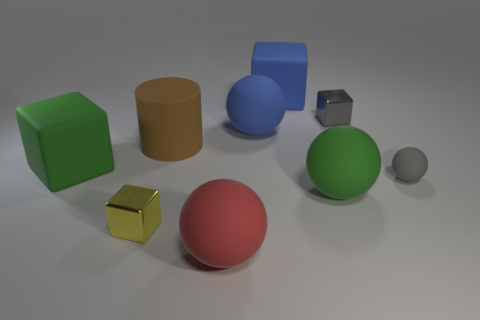There is a gray thing that is behind the gray matte object; is its size the same as the yellow metallic object?
Keep it short and to the point. Yes. There is a big red matte object; what shape is it?
Ensure brevity in your answer.  Sphere. There is a shiny block that is the same color as the small rubber ball; what is its size?
Your answer should be compact. Small. Are the small cube that is behind the green rubber ball and the large cylinder made of the same material?
Offer a very short reply. No. Are there any other matte balls that have the same color as the tiny matte sphere?
Keep it short and to the point. No. There is a metallic thing to the right of the red matte sphere; is its shape the same as the metal object that is left of the green rubber ball?
Make the answer very short. Yes. Are there any spheres that have the same material as the large brown cylinder?
Provide a short and direct response. Yes. How many yellow things are big rubber objects or small objects?
Offer a terse response. 1. How big is the block that is both left of the green matte sphere and on the right side of the brown matte thing?
Your answer should be compact. Large. Are there more big brown cylinders that are to the right of the cylinder than big brown objects?
Your response must be concise. No. 